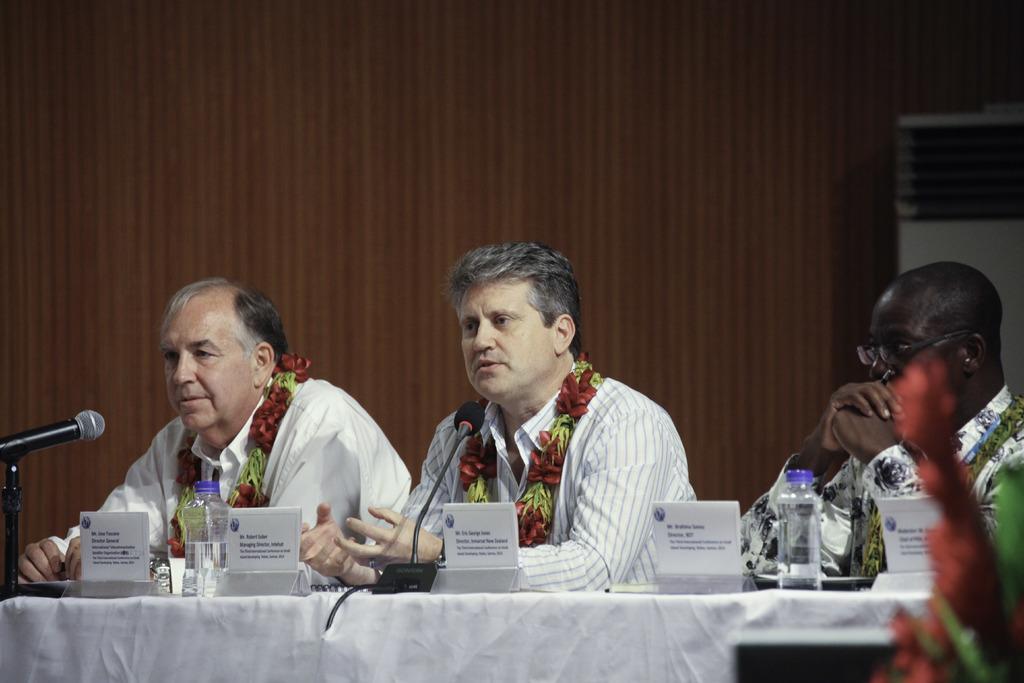Please provide a concise description of this image. In this image I can see three persons sitting. The person in the middle wearing white shirt, in front I can see two microphones, bottles and few boards on the table. Background I can see the wall in brown color. 